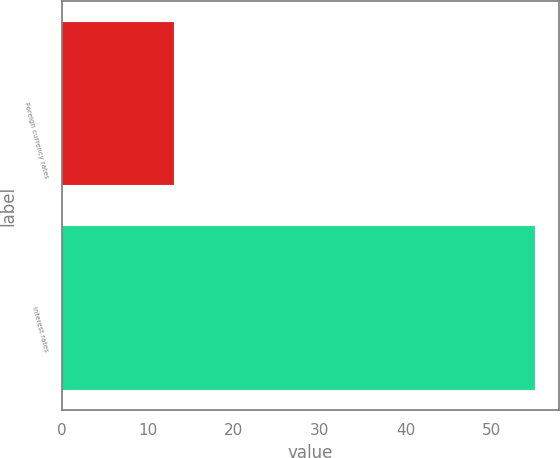Convert chart to OTSL. <chart><loc_0><loc_0><loc_500><loc_500><bar_chart><fcel>Foreign currency rates<fcel>Interest rates<nl><fcel>13<fcel>55<nl></chart> 